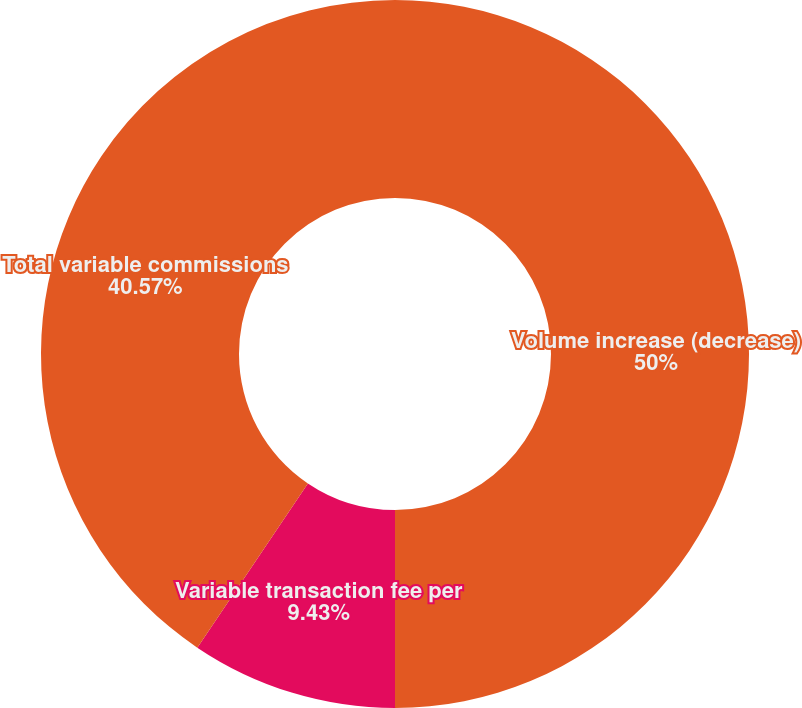Convert chart. <chart><loc_0><loc_0><loc_500><loc_500><pie_chart><fcel>Volume increase (decrease)<fcel>Variable transaction fee per<fcel>Total variable commissions<nl><fcel>50.0%<fcel>9.43%<fcel>40.57%<nl></chart> 